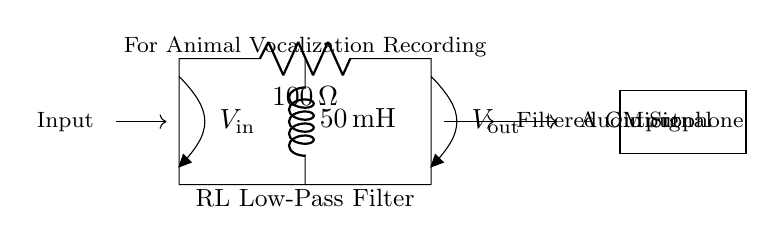What is the resistance value in the circuit? The resistance component labeled as R has a value of 100 ohms as indicated on the circuit diagram.
Answer: 100 ohms What is the inductance value of the inductor? The inductor component labeled as L has a value of 50 millihenries as shown in the circuit diagram.
Answer: 50 millihenries What type of filter is represented by this circuit? The circuit diagram is labeled as an RL Low-Pass Filter which means it allows low-frequency signals to pass while attenuating high-frequency signals.
Answer: Low-Pass Filter What is the input signal labeled as? The circuit diagram labels the input signal at the left side as V in, which indicates the voltage of the input audio signal given to the circuit.
Answer: V in What can be inferred about the output from the circuit? The output labeled as V out shows that it represents the filtered audio signal after it has passed through the circuit, suggesting a modified signal suitable for further audio processing or analysis.
Answer: Filtered Output How do the components work together in this circuit? The resistor and inductor work together to form a low-pass filter. The resistor limits the current and dissipates energy, while the inductor stores energy in a magnetic field, allowing low frequencies to pass and filtering out higher frequencies.
Answer: They form a low-pass filter What does the microphone in the circuit do? The microphone is labeled and indicates that it converts sound, specifically animal vocalizations in this context, into an electrical audio signal to be processed by the RL filter.
Answer: Converts sound to audio signal 